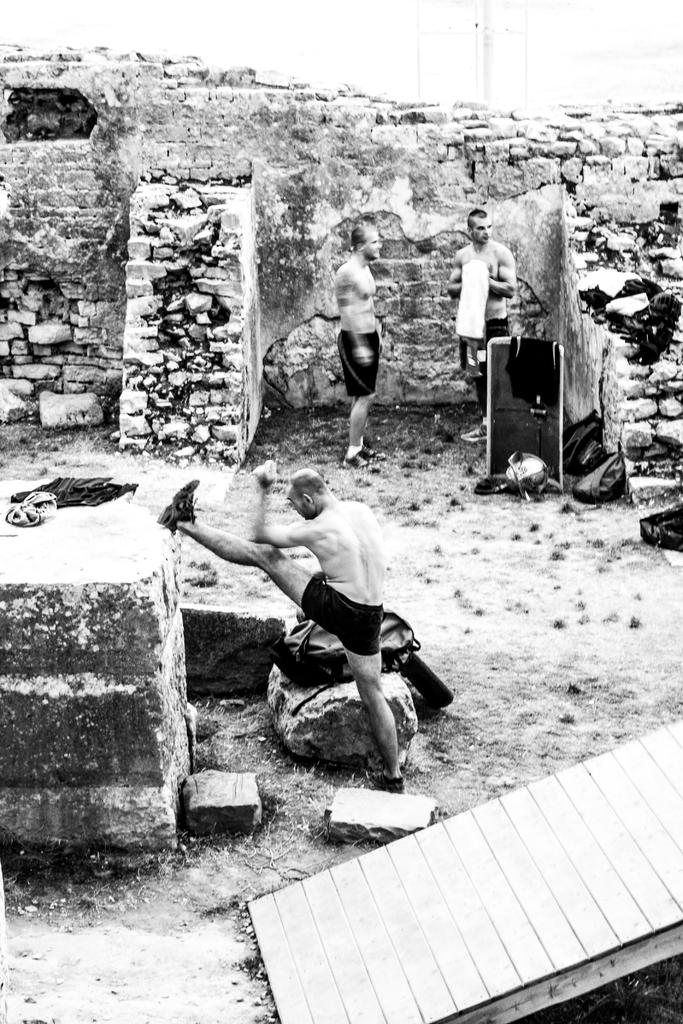What is the person in the image doing? The person is doing exercise on the ground. Where is the person doing exercise located in relation to other objects? The person is near a wall. What can be seen on the rock near the person? There is a bag on a rock near the person. What is happening in the background of the image? In the background, there are two persons standing. Where are the two persons standing in relation to other objects? The two persons are near a brick wall. What discovery did the person make while doing exercise in the image? There is no indication of a discovery in the image; the person is simply doing exercise on the ground. 